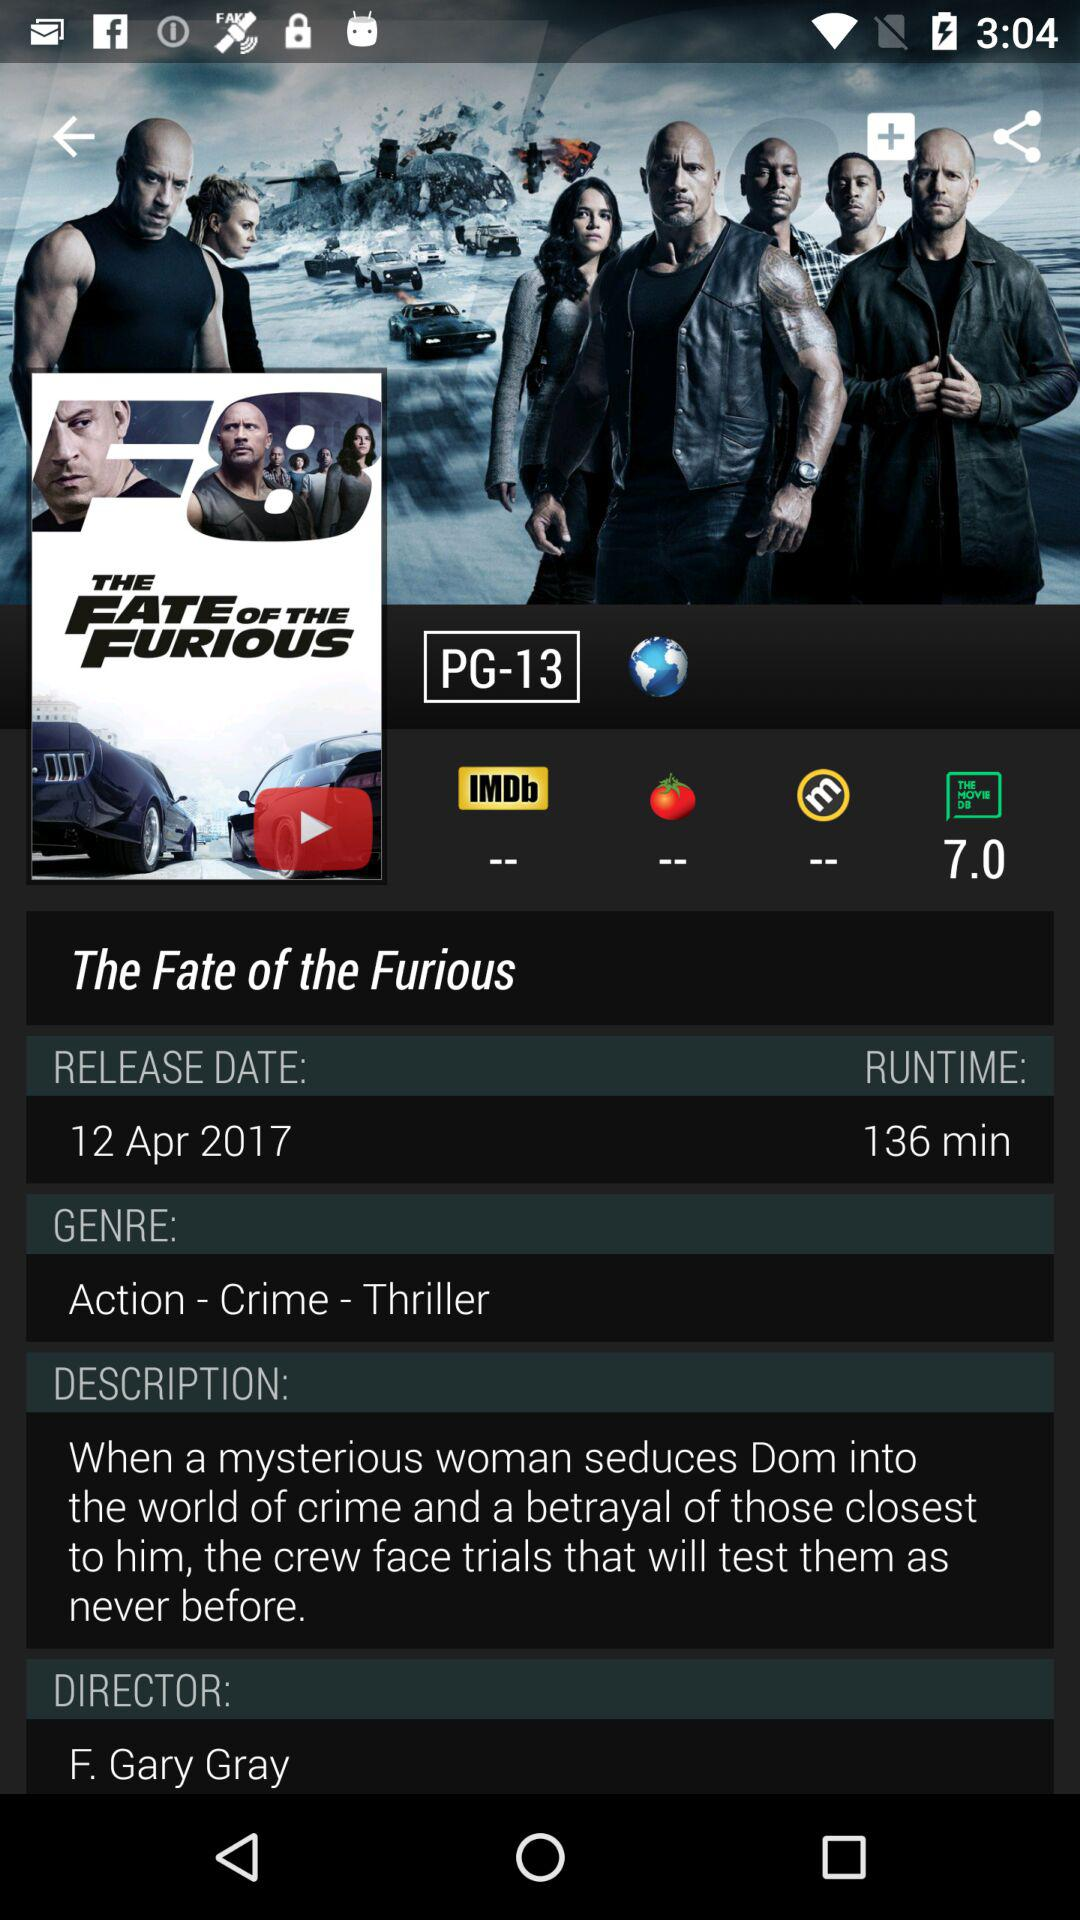Who is the director of the movie? The director of the movie is F. Gary Gray. 